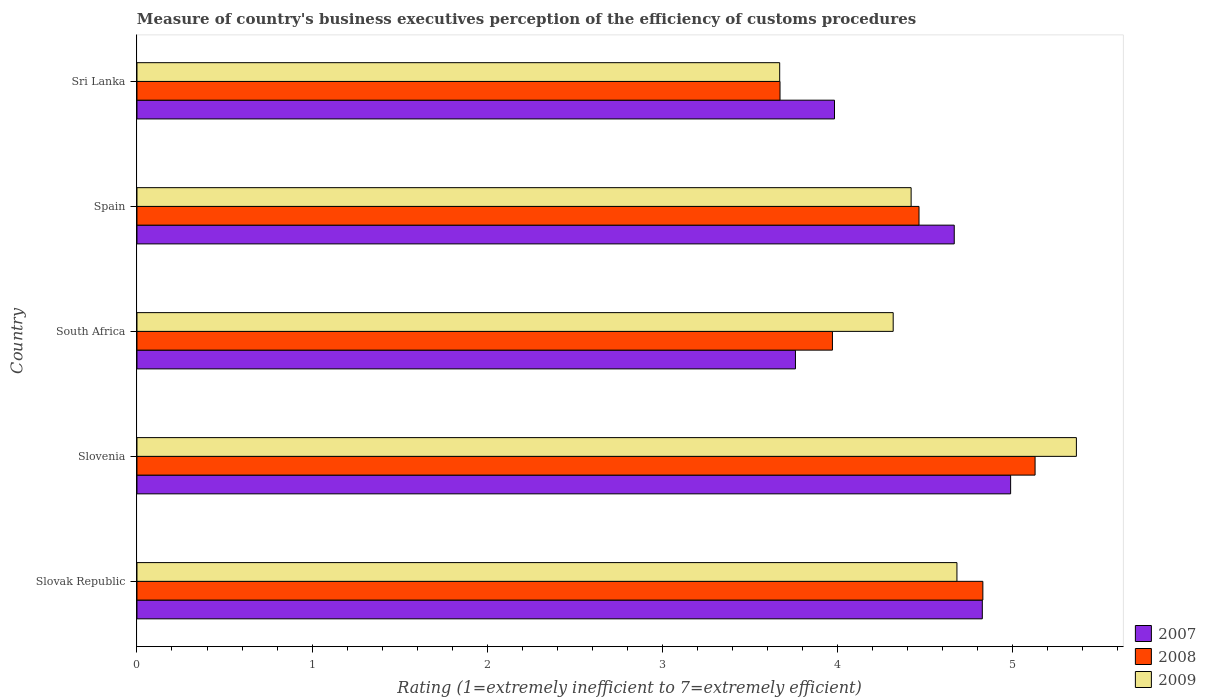How many different coloured bars are there?
Your response must be concise. 3. Are the number of bars per tick equal to the number of legend labels?
Your answer should be compact. Yes. How many bars are there on the 4th tick from the bottom?
Ensure brevity in your answer.  3. What is the label of the 4th group of bars from the top?
Your response must be concise. Slovenia. What is the rating of the efficiency of customs procedure in 2009 in Sri Lanka?
Make the answer very short. 3.67. Across all countries, what is the maximum rating of the efficiency of customs procedure in 2009?
Your answer should be very brief. 5.36. Across all countries, what is the minimum rating of the efficiency of customs procedure in 2007?
Offer a very short reply. 3.76. In which country was the rating of the efficiency of customs procedure in 2007 maximum?
Give a very brief answer. Slovenia. In which country was the rating of the efficiency of customs procedure in 2009 minimum?
Provide a succinct answer. Sri Lanka. What is the total rating of the efficiency of customs procedure in 2007 in the graph?
Your response must be concise. 22.23. What is the difference between the rating of the efficiency of customs procedure in 2009 in Slovenia and that in Spain?
Your response must be concise. 0.94. What is the difference between the rating of the efficiency of customs procedure in 2008 in Sri Lanka and the rating of the efficiency of customs procedure in 2009 in Slovenia?
Make the answer very short. -1.69. What is the average rating of the efficiency of customs procedure in 2007 per country?
Offer a terse response. 4.45. What is the difference between the rating of the efficiency of customs procedure in 2007 and rating of the efficiency of customs procedure in 2008 in Slovak Republic?
Ensure brevity in your answer.  -0. What is the ratio of the rating of the efficiency of customs procedure in 2009 in Slovak Republic to that in Slovenia?
Your answer should be compact. 0.87. Is the rating of the efficiency of customs procedure in 2007 in South Africa less than that in Spain?
Provide a succinct answer. Yes. What is the difference between the highest and the second highest rating of the efficiency of customs procedure in 2008?
Offer a very short reply. 0.3. What is the difference between the highest and the lowest rating of the efficiency of customs procedure in 2008?
Offer a terse response. 1.46. What does the 1st bar from the bottom in Spain represents?
Offer a terse response. 2007. Is it the case that in every country, the sum of the rating of the efficiency of customs procedure in 2009 and rating of the efficiency of customs procedure in 2007 is greater than the rating of the efficiency of customs procedure in 2008?
Provide a short and direct response. Yes. How many bars are there?
Your response must be concise. 15. What is the difference between two consecutive major ticks on the X-axis?
Make the answer very short. 1. Are the values on the major ticks of X-axis written in scientific E-notation?
Ensure brevity in your answer.  No. Does the graph contain grids?
Provide a succinct answer. No. How many legend labels are there?
Offer a terse response. 3. What is the title of the graph?
Give a very brief answer. Measure of country's business executives perception of the efficiency of customs procedures. What is the label or title of the X-axis?
Keep it short and to the point. Rating (1=extremely inefficient to 7=extremely efficient). What is the Rating (1=extremely inefficient to 7=extremely efficient) in 2007 in Slovak Republic?
Provide a succinct answer. 4.83. What is the Rating (1=extremely inefficient to 7=extremely efficient) of 2008 in Slovak Republic?
Ensure brevity in your answer.  4.83. What is the Rating (1=extremely inefficient to 7=extremely efficient) in 2009 in Slovak Republic?
Your response must be concise. 4.68. What is the Rating (1=extremely inefficient to 7=extremely efficient) of 2007 in Slovenia?
Your answer should be very brief. 4.99. What is the Rating (1=extremely inefficient to 7=extremely efficient) of 2008 in Slovenia?
Your response must be concise. 5.13. What is the Rating (1=extremely inefficient to 7=extremely efficient) of 2009 in Slovenia?
Give a very brief answer. 5.36. What is the Rating (1=extremely inefficient to 7=extremely efficient) of 2007 in South Africa?
Your answer should be very brief. 3.76. What is the Rating (1=extremely inefficient to 7=extremely efficient) in 2008 in South Africa?
Keep it short and to the point. 3.97. What is the Rating (1=extremely inefficient to 7=extremely efficient) of 2009 in South Africa?
Provide a short and direct response. 4.32. What is the Rating (1=extremely inefficient to 7=extremely efficient) in 2007 in Spain?
Provide a short and direct response. 4.67. What is the Rating (1=extremely inefficient to 7=extremely efficient) in 2008 in Spain?
Your answer should be very brief. 4.47. What is the Rating (1=extremely inefficient to 7=extremely efficient) of 2009 in Spain?
Give a very brief answer. 4.42. What is the Rating (1=extremely inefficient to 7=extremely efficient) of 2007 in Sri Lanka?
Offer a very short reply. 3.98. What is the Rating (1=extremely inefficient to 7=extremely efficient) in 2008 in Sri Lanka?
Your answer should be very brief. 3.67. What is the Rating (1=extremely inefficient to 7=extremely efficient) in 2009 in Sri Lanka?
Give a very brief answer. 3.67. Across all countries, what is the maximum Rating (1=extremely inefficient to 7=extremely efficient) of 2007?
Offer a terse response. 4.99. Across all countries, what is the maximum Rating (1=extremely inefficient to 7=extremely efficient) of 2008?
Ensure brevity in your answer.  5.13. Across all countries, what is the maximum Rating (1=extremely inefficient to 7=extremely efficient) in 2009?
Provide a succinct answer. 5.36. Across all countries, what is the minimum Rating (1=extremely inefficient to 7=extremely efficient) of 2007?
Offer a terse response. 3.76. Across all countries, what is the minimum Rating (1=extremely inefficient to 7=extremely efficient) of 2008?
Give a very brief answer. 3.67. Across all countries, what is the minimum Rating (1=extremely inefficient to 7=extremely efficient) of 2009?
Ensure brevity in your answer.  3.67. What is the total Rating (1=extremely inefficient to 7=extremely efficient) of 2007 in the graph?
Ensure brevity in your answer.  22.23. What is the total Rating (1=extremely inefficient to 7=extremely efficient) in 2008 in the graph?
Keep it short and to the point. 22.07. What is the total Rating (1=extremely inefficient to 7=extremely efficient) in 2009 in the graph?
Make the answer very short. 22.45. What is the difference between the Rating (1=extremely inefficient to 7=extremely efficient) of 2007 in Slovak Republic and that in Slovenia?
Provide a succinct answer. -0.16. What is the difference between the Rating (1=extremely inefficient to 7=extremely efficient) of 2008 in Slovak Republic and that in Slovenia?
Your answer should be very brief. -0.3. What is the difference between the Rating (1=extremely inefficient to 7=extremely efficient) in 2009 in Slovak Republic and that in Slovenia?
Your response must be concise. -0.68. What is the difference between the Rating (1=extremely inefficient to 7=extremely efficient) of 2007 in Slovak Republic and that in South Africa?
Your response must be concise. 1.07. What is the difference between the Rating (1=extremely inefficient to 7=extremely efficient) in 2008 in Slovak Republic and that in South Africa?
Give a very brief answer. 0.86. What is the difference between the Rating (1=extremely inefficient to 7=extremely efficient) of 2009 in Slovak Republic and that in South Africa?
Your response must be concise. 0.36. What is the difference between the Rating (1=extremely inefficient to 7=extremely efficient) in 2007 in Slovak Republic and that in Spain?
Make the answer very short. 0.16. What is the difference between the Rating (1=extremely inefficient to 7=extremely efficient) in 2008 in Slovak Republic and that in Spain?
Keep it short and to the point. 0.36. What is the difference between the Rating (1=extremely inefficient to 7=extremely efficient) of 2009 in Slovak Republic and that in Spain?
Make the answer very short. 0.26. What is the difference between the Rating (1=extremely inefficient to 7=extremely efficient) in 2007 in Slovak Republic and that in Sri Lanka?
Your response must be concise. 0.84. What is the difference between the Rating (1=extremely inefficient to 7=extremely efficient) of 2008 in Slovak Republic and that in Sri Lanka?
Offer a very short reply. 1.16. What is the difference between the Rating (1=extremely inefficient to 7=extremely efficient) in 2009 in Slovak Republic and that in Sri Lanka?
Your response must be concise. 1.01. What is the difference between the Rating (1=extremely inefficient to 7=extremely efficient) of 2007 in Slovenia and that in South Africa?
Give a very brief answer. 1.23. What is the difference between the Rating (1=extremely inefficient to 7=extremely efficient) in 2008 in Slovenia and that in South Africa?
Your answer should be compact. 1.16. What is the difference between the Rating (1=extremely inefficient to 7=extremely efficient) of 2009 in Slovenia and that in South Africa?
Ensure brevity in your answer.  1.05. What is the difference between the Rating (1=extremely inefficient to 7=extremely efficient) of 2007 in Slovenia and that in Spain?
Provide a short and direct response. 0.32. What is the difference between the Rating (1=extremely inefficient to 7=extremely efficient) of 2008 in Slovenia and that in Spain?
Keep it short and to the point. 0.66. What is the difference between the Rating (1=extremely inefficient to 7=extremely efficient) in 2009 in Slovenia and that in Spain?
Your answer should be compact. 0.94. What is the difference between the Rating (1=extremely inefficient to 7=extremely efficient) in 2008 in Slovenia and that in Sri Lanka?
Give a very brief answer. 1.46. What is the difference between the Rating (1=extremely inefficient to 7=extremely efficient) in 2009 in Slovenia and that in Sri Lanka?
Offer a very short reply. 1.69. What is the difference between the Rating (1=extremely inefficient to 7=extremely efficient) in 2007 in South Africa and that in Spain?
Make the answer very short. -0.91. What is the difference between the Rating (1=extremely inefficient to 7=extremely efficient) in 2008 in South Africa and that in Spain?
Offer a terse response. -0.49. What is the difference between the Rating (1=extremely inefficient to 7=extremely efficient) in 2009 in South Africa and that in Spain?
Offer a terse response. -0.1. What is the difference between the Rating (1=extremely inefficient to 7=extremely efficient) of 2007 in South Africa and that in Sri Lanka?
Offer a very short reply. -0.22. What is the difference between the Rating (1=extremely inefficient to 7=extremely efficient) of 2008 in South Africa and that in Sri Lanka?
Offer a terse response. 0.3. What is the difference between the Rating (1=extremely inefficient to 7=extremely efficient) of 2009 in South Africa and that in Sri Lanka?
Your response must be concise. 0.65. What is the difference between the Rating (1=extremely inefficient to 7=extremely efficient) in 2007 in Spain and that in Sri Lanka?
Give a very brief answer. 0.68. What is the difference between the Rating (1=extremely inefficient to 7=extremely efficient) of 2008 in Spain and that in Sri Lanka?
Make the answer very short. 0.79. What is the difference between the Rating (1=extremely inefficient to 7=extremely efficient) in 2009 in Spain and that in Sri Lanka?
Your response must be concise. 0.75. What is the difference between the Rating (1=extremely inefficient to 7=extremely efficient) in 2007 in Slovak Republic and the Rating (1=extremely inefficient to 7=extremely efficient) in 2008 in Slovenia?
Provide a succinct answer. -0.3. What is the difference between the Rating (1=extremely inefficient to 7=extremely efficient) of 2007 in Slovak Republic and the Rating (1=extremely inefficient to 7=extremely efficient) of 2009 in Slovenia?
Your answer should be very brief. -0.54. What is the difference between the Rating (1=extremely inefficient to 7=extremely efficient) of 2008 in Slovak Republic and the Rating (1=extremely inefficient to 7=extremely efficient) of 2009 in Slovenia?
Make the answer very short. -0.53. What is the difference between the Rating (1=extremely inefficient to 7=extremely efficient) of 2007 in Slovak Republic and the Rating (1=extremely inefficient to 7=extremely efficient) of 2008 in South Africa?
Your answer should be very brief. 0.86. What is the difference between the Rating (1=extremely inefficient to 7=extremely efficient) in 2007 in Slovak Republic and the Rating (1=extremely inefficient to 7=extremely efficient) in 2009 in South Africa?
Your response must be concise. 0.51. What is the difference between the Rating (1=extremely inefficient to 7=extremely efficient) of 2008 in Slovak Republic and the Rating (1=extremely inefficient to 7=extremely efficient) of 2009 in South Africa?
Offer a terse response. 0.51. What is the difference between the Rating (1=extremely inefficient to 7=extremely efficient) in 2007 in Slovak Republic and the Rating (1=extremely inefficient to 7=extremely efficient) in 2008 in Spain?
Keep it short and to the point. 0.36. What is the difference between the Rating (1=extremely inefficient to 7=extremely efficient) of 2007 in Slovak Republic and the Rating (1=extremely inefficient to 7=extremely efficient) of 2009 in Spain?
Ensure brevity in your answer.  0.41. What is the difference between the Rating (1=extremely inefficient to 7=extremely efficient) of 2008 in Slovak Republic and the Rating (1=extremely inefficient to 7=extremely efficient) of 2009 in Spain?
Your answer should be very brief. 0.41. What is the difference between the Rating (1=extremely inefficient to 7=extremely efficient) of 2007 in Slovak Republic and the Rating (1=extremely inefficient to 7=extremely efficient) of 2008 in Sri Lanka?
Ensure brevity in your answer.  1.16. What is the difference between the Rating (1=extremely inefficient to 7=extremely efficient) in 2007 in Slovak Republic and the Rating (1=extremely inefficient to 7=extremely efficient) in 2009 in Sri Lanka?
Your answer should be very brief. 1.16. What is the difference between the Rating (1=extremely inefficient to 7=extremely efficient) in 2008 in Slovak Republic and the Rating (1=extremely inefficient to 7=extremely efficient) in 2009 in Sri Lanka?
Your answer should be very brief. 1.16. What is the difference between the Rating (1=extremely inefficient to 7=extremely efficient) of 2007 in Slovenia and the Rating (1=extremely inefficient to 7=extremely efficient) of 2008 in South Africa?
Your answer should be very brief. 1.02. What is the difference between the Rating (1=extremely inefficient to 7=extremely efficient) of 2007 in Slovenia and the Rating (1=extremely inefficient to 7=extremely efficient) of 2009 in South Africa?
Provide a succinct answer. 0.67. What is the difference between the Rating (1=extremely inefficient to 7=extremely efficient) of 2008 in Slovenia and the Rating (1=extremely inefficient to 7=extremely efficient) of 2009 in South Africa?
Offer a terse response. 0.81. What is the difference between the Rating (1=extremely inefficient to 7=extremely efficient) of 2007 in Slovenia and the Rating (1=extremely inefficient to 7=extremely efficient) of 2008 in Spain?
Keep it short and to the point. 0.52. What is the difference between the Rating (1=extremely inefficient to 7=extremely efficient) of 2007 in Slovenia and the Rating (1=extremely inefficient to 7=extremely efficient) of 2009 in Spain?
Provide a short and direct response. 0.57. What is the difference between the Rating (1=extremely inefficient to 7=extremely efficient) of 2008 in Slovenia and the Rating (1=extremely inefficient to 7=extremely efficient) of 2009 in Spain?
Provide a succinct answer. 0.71. What is the difference between the Rating (1=extremely inefficient to 7=extremely efficient) in 2007 in Slovenia and the Rating (1=extremely inefficient to 7=extremely efficient) in 2008 in Sri Lanka?
Offer a very short reply. 1.32. What is the difference between the Rating (1=extremely inefficient to 7=extremely efficient) in 2007 in Slovenia and the Rating (1=extremely inefficient to 7=extremely efficient) in 2009 in Sri Lanka?
Your response must be concise. 1.32. What is the difference between the Rating (1=extremely inefficient to 7=extremely efficient) of 2008 in Slovenia and the Rating (1=extremely inefficient to 7=extremely efficient) of 2009 in Sri Lanka?
Provide a succinct answer. 1.46. What is the difference between the Rating (1=extremely inefficient to 7=extremely efficient) of 2007 in South Africa and the Rating (1=extremely inefficient to 7=extremely efficient) of 2008 in Spain?
Offer a very short reply. -0.71. What is the difference between the Rating (1=extremely inefficient to 7=extremely efficient) of 2007 in South Africa and the Rating (1=extremely inefficient to 7=extremely efficient) of 2009 in Spain?
Your response must be concise. -0.66. What is the difference between the Rating (1=extremely inefficient to 7=extremely efficient) of 2008 in South Africa and the Rating (1=extremely inefficient to 7=extremely efficient) of 2009 in Spain?
Offer a very short reply. -0.45. What is the difference between the Rating (1=extremely inefficient to 7=extremely efficient) in 2007 in South Africa and the Rating (1=extremely inefficient to 7=extremely efficient) in 2008 in Sri Lanka?
Your answer should be very brief. 0.09. What is the difference between the Rating (1=extremely inefficient to 7=extremely efficient) in 2007 in South Africa and the Rating (1=extremely inefficient to 7=extremely efficient) in 2009 in Sri Lanka?
Make the answer very short. 0.09. What is the difference between the Rating (1=extremely inefficient to 7=extremely efficient) of 2008 in South Africa and the Rating (1=extremely inefficient to 7=extremely efficient) of 2009 in Sri Lanka?
Your response must be concise. 0.3. What is the difference between the Rating (1=extremely inefficient to 7=extremely efficient) of 2007 in Spain and the Rating (1=extremely inefficient to 7=extremely efficient) of 2009 in Sri Lanka?
Provide a succinct answer. 1. What is the difference between the Rating (1=extremely inefficient to 7=extremely efficient) of 2008 in Spain and the Rating (1=extremely inefficient to 7=extremely efficient) of 2009 in Sri Lanka?
Provide a short and direct response. 0.8. What is the average Rating (1=extremely inefficient to 7=extremely efficient) in 2007 per country?
Provide a short and direct response. 4.45. What is the average Rating (1=extremely inefficient to 7=extremely efficient) of 2008 per country?
Your answer should be very brief. 4.41. What is the average Rating (1=extremely inefficient to 7=extremely efficient) of 2009 per country?
Give a very brief answer. 4.49. What is the difference between the Rating (1=extremely inefficient to 7=extremely efficient) in 2007 and Rating (1=extremely inefficient to 7=extremely efficient) in 2008 in Slovak Republic?
Your response must be concise. -0. What is the difference between the Rating (1=extremely inefficient to 7=extremely efficient) of 2007 and Rating (1=extremely inefficient to 7=extremely efficient) of 2009 in Slovak Republic?
Provide a short and direct response. 0.14. What is the difference between the Rating (1=extremely inefficient to 7=extremely efficient) in 2008 and Rating (1=extremely inefficient to 7=extremely efficient) in 2009 in Slovak Republic?
Provide a short and direct response. 0.15. What is the difference between the Rating (1=extremely inefficient to 7=extremely efficient) in 2007 and Rating (1=extremely inefficient to 7=extremely efficient) in 2008 in Slovenia?
Your answer should be very brief. -0.14. What is the difference between the Rating (1=extremely inefficient to 7=extremely efficient) of 2007 and Rating (1=extremely inefficient to 7=extremely efficient) of 2009 in Slovenia?
Give a very brief answer. -0.38. What is the difference between the Rating (1=extremely inefficient to 7=extremely efficient) of 2008 and Rating (1=extremely inefficient to 7=extremely efficient) of 2009 in Slovenia?
Your answer should be very brief. -0.24. What is the difference between the Rating (1=extremely inefficient to 7=extremely efficient) in 2007 and Rating (1=extremely inefficient to 7=extremely efficient) in 2008 in South Africa?
Provide a short and direct response. -0.21. What is the difference between the Rating (1=extremely inefficient to 7=extremely efficient) of 2007 and Rating (1=extremely inefficient to 7=extremely efficient) of 2009 in South Africa?
Your answer should be very brief. -0.56. What is the difference between the Rating (1=extremely inefficient to 7=extremely efficient) in 2008 and Rating (1=extremely inefficient to 7=extremely efficient) in 2009 in South Africa?
Your answer should be very brief. -0.35. What is the difference between the Rating (1=extremely inefficient to 7=extremely efficient) in 2007 and Rating (1=extremely inefficient to 7=extremely efficient) in 2008 in Spain?
Your response must be concise. 0.2. What is the difference between the Rating (1=extremely inefficient to 7=extremely efficient) of 2007 and Rating (1=extremely inefficient to 7=extremely efficient) of 2009 in Spain?
Give a very brief answer. 0.25. What is the difference between the Rating (1=extremely inefficient to 7=extremely efficient) in 2008 and Rating (1=extremely inefficient to 7=extremely efficient) in 2009 in Spain?
Offer a very short reply. 0.05. What is the difference between the Rating (1=extremely inefficient to 7=extremely efficient) in 2007 and Rating (1=extremely inefficient to 7=extremely efficient) in 2008 in Sri Lanka?
Give a very brief answer. 0.31. What is the difference between the Rating (1=extremely inefficient to 7=extremely efficient) of 2007 and Rating (1=extremely inefficient to 7=extremely efficient) of 2009 in Sri Lanka?
Your response must be concise. 0.31. What is the difference between the Rating (1=extremely inefficient to 7=extremely efficient) of 2008 and Rating (1=extremely inefficient to 7=extremely efficient) of 2009 in Sri Lanka?
Your answer should be very brief. 0. What is the ratio of the Rating (1=extremely inefficient to 7=extremely efficient) in 2007 in Slovak Republic to that in Slovenia?
Offer a very short reply. 0.97. What is the ratio of the Rating (1=extremely inefficient to 7=extremely efficient) of 2008 in Slovak Republic to that in Slovenia?
Ensure brevity in your answer.  0.94. What is the ratio of the Rating (1=extremely inefficient to 7=extremely efficient) in 2009 in Slovak Republic to that in Slovenia?
Your answer should be compact. 0.87. What is the ratio of the Rating (1=extremely inefficient to 7=extremely efficient) in 2007 in Slovak Republic to that in South Africa?
Your answer should be very brief. 1.28. What is the ratio of the Rating (1=extremely inefficient to 7=extremely efficient) in 2008 in Slovak Republic to that in South Africa?
Provide a succinct answer. 1.22. What is the ratio of the Rating (1=extremely inefficient to 7=extremely efficient) in 2009 in Slovak Republic to that in South Africa?
Offer a very short reply. 1.08. What is the ratio of the Rating (1=extremely inefficient to 7=extremely efficient) of 2007 in Slovak Republic to that in Spain?
Make the answer very short. 1.03. What is the ratio of the Rating (1=extremely inefficient to 7=extremely efficient) of 2008 in Slovak Republic to that in Spain?
Give a very brief answer. 1.08. What is the ratio of the Rating (1=extremely inefficient to 7=extremely efficient) in 2009 in Slovak Republic to that in Spain?
Ensure brevity in your answer.  1.06. What is the ratio of the Rating (1=extremely inefficient to 7=extremely efficient) in 2007 in Slovak Republic to that in Sri Lanka?
Provide a succinct answer. 1.21. What is the ratio of the Rating (1=extremely inefficient to 7=extremely efficient) in 2008 in Slovak Republic to that in Sri Lanka?
Your answer should be compact. 1.32. What is the ratio of the Rating (1=extremely inefficient to 7=extremely efficient) in 2009 in Slovak Republic to that in Sri Lanka?
Your answer should be compact. 1.28. What is the ratio of the Rating (1=extremely inefficient to 7=extremely efficient) in 2007 in Slovenia to that in South Africa?
Your answer should be compact. 1.33. What is the ratio of the Rating (1=extremely inefficient to 7=extremely efficient) of 2008 in Slovenia to that in South Africa?
Offer a very short reply. 1.29. What is the ratio of the Rating (1=extremely inefficient to 7=extremely efficient) in 2009 in Slovenia to that in South Africa?
Your response must be concise. 1.24. What is the ratio of the Rating (1=extremely inefficient to 7=extremely efficient) of 2007 in Slovenia to that in Spain?
Provide a succinct answer. 1.07. What is the ratio of the Rating (1=extremely inefficient to 7=extremely efficient) in 2008 in Slovenia to that in Spain?
Your answer should be compact. 1.15. What is the ratio of the Rating (1=extremely inefficient to 7=extremely efficient) of 2009 in Slovenia to that in Spain?
Offer a terse response. 1.21. What is the ratio of the Rating (1=extremely inefficient to 7=extremely efficient) of 2007 in Slovenia to that in Sri Lanka?
Offer a terse response. 1.25. What is the ratio of the Rating (1=extremely inefficient to 7=extremely efficient) in 2008 in Slovenia to that in Sri Lanka?
Your response must be concise. 1.4. What is the ratio of the Rating (1=extremely inefficient to 7=extremely efficient) in 2009 in Slovenia to that in Sri Lanka?
Offer a terse response. 1.46. What is the ratio of the Rating (1=extremely inefficient to 7=extremely efficient) of 2007 in South Africa to that in Spain?
Keep it short and to the point. 0.81. What is the ratio of the Rating (1=extremely inefficient to 7=extremely efficient) of 2008 in South Africa to that in Spain?
Your answer should be very brief. 0.89. What is the ratio of the Rating (1=extremely inefficient to 7=extremely efficient) of 2009 in South Africa to that in Spain?
Ensure brevity in your answer.  0.98. What is the ratio of the Rating (1=extremely inefficient to 7=extremely efficient) of 2007 in South Africa to that in Sri Lanka?
Make the answer very short. 0.94. What is the ratio of the Rating (1=extremely inefficient to 7=extremely efficient) in 2008 in South Africa to that in Sri Lanka?
Keep it short and to the point. 1.08. What is the ratio of the Rating (1=extremely inefficient to 7=extremely efficient) of 2009 in South Africa to that in Sri Lanka?
Offer a very short reply. 1.18. What is the ratio of the Rating (1=extremely inefficient to 7=extremely efficient) in 2007 in Spain to that in Sri Lanka?
Provide a short and direct response. 1.17. What is the ratio of the Rating (1=extremely inefficient to 7=extremely efficient) of 2008 in Spain to that in Sri Lanka?
Ensure brevity in your answer.  1.22. What is the ratio of the Rating (1=extremely inefficient to 7=extremely efficient) of 2009 in Spain to that in Sri Lanka?
Your answer should be compact. 1.2. What is the difference between the highest and the second highest Rating (1=extremely inefficient to 7=extremely efficient) in 2007?
Offer a terse response. 0.16. What is the difference between the highest and the second highest Rating (1=extremely inefficient to 7=extremely efficient) of 2008?
Offer a terse response. 0.3. What is the difference between the highest and the second highest Rating (1=extremely inefficient to 7=extremely efficient) in 2009?
Offer a terse response. 0.68. What is the difference between the highest and the lowest Rating (1=extremely inefficient to 7=extremely efficient) in 2007?
Give a very brief answer. 1.23. What is the difference between the highest and the lowest Rating (1=extremely inefficient to 7=extremely efficient) of 2008?
Provide a succinct answer. 1.46. What is the difference between the highest and the lowest Rating (1=extremely inefficient to 7=extremely efficient) of 2009?
Make the answer very short. 1.69. 